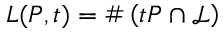Convert formula to latex. <formula><loc_0><loc_0><loc_500><loc_500>L ( P , t ) = \# \left ( t P \cap { \mathcal { L } } \right )</formula> 